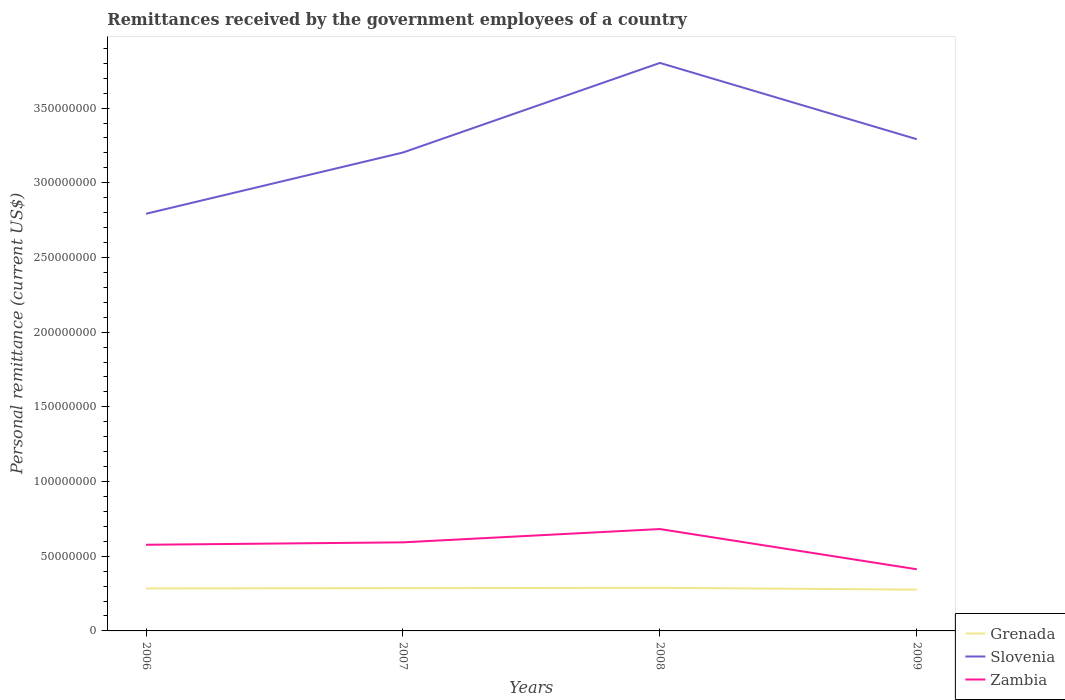Is the number of lines equal to the number of legend labels?
Your response must be concise. Yes. Across all years, what is the maximum remittances received by the government employees in Slovenia?
Offer a very short reply. 2.79e+08. In which year was the remittances received by the government employees in Slovenia maximum?
Offer a terse response. 2006. What is the total remittances received by the government employees in Zambia in the graph?
Your response must be concise. 1.64e+07. What is the difference between the highest and the second highest remittances received by the government employees in Grenada?
Provide a short and direct response. 1.20e+06. What is the difference between the highest and the lowest remittances received by the government employees in Grenada?
Make the answer very short. 3. What is the difference between two consecutive major ticks on the Y-axis?
Your answer should be very brief. 5.00e+07. Does the graph contain any zero values?
Give a very brief answer. No. Does the graph contain grids?
Your answer should be compact. No. Where does the legend appear in the graph?
Provide a short and direct response. Bottom right. How are the legend labels stacked?
Keep it short and to the point. Vertical. What is the title of the graph?
Ensure brevity in your answer.  Remittances received by the government employees of a country. Does "Tonga" appear as one of the legend labels in the graph?
Your answer should be compact. No. What is the label or title of the Y-axis?
Your response must be concise. Personal remittance (current US$). What is the Personal remittance (current US$) in Grenada in 2006?
Your answer should be compact. 2.84e+07. What is the Personal remittance (current US$) in Slovenia in 2006?
Provide a succinct answer. 2.79e+08. What is the Personal remittance (current US$) of Zambia in 2006?
Provide a short and direct response. 5.77e+07. What is the Personal remittance (current US$) of Grenada in 2007?
Keep it short and to the point. 2.86e+07. What is the Personal remittance (current US$) in Slovenia in 2007?
Your answer should be very brief. 3.20e+08. What is the Personal remittance (current US$) of Zambia in 2007?
Provide a succinct answer. 5.93e+07. What is the Personal remittance (current US$) of Grenada in 2008?
Give a very brief answer. 2.89e+07. What is the Personal remittance (current US$) in Slovenia in 2008?
Offer a very short reply. 3.80e+08. What is the Personal remittance (current US$) in Zambia in 2008?
Offer a terse response. 6.82e+07. What is the Personal remittance (current US$) of Grenada in 2009?
Provide a short and direct response. 2.77e+07. What is the Personal remittance (current US$) in Slovenia in 2009?
Keep it short and to the point. 3.29e+08. What is the Personal remittance (current US$) of Zambia in 2009?
Offer a very short reply. 4.13e+07. Across all years, what is the maximum Personal remittance (current US$) in Grenada?
Your response must be concise. 2.89e+07. Across all years, what is the maximum Personal remittance (current US$) of Slovenia?
Offer a very short reply. 3.80e+08. Across all years, what is the maximum Personal remittance (current US$) in Zambia?
Make the answer very short. 6.82e+07. Across all years, what is the minimum Personal remittance (current US$) in Grenada?
Offer a terse response. 2.77e+07. Across all years, what is the minimum Personal remittance (current US$) of Slovenia?
Your answer should be very brief. 2.79e+08. Across all years, what is the minimum Personal remittance (current US$) in Zambia?
Your answer should be very brief. 4.13e+07. What is the total Personal remittance (current US$) in Grenada in the graph?
Keep it short and to the point. 1.14e+08. What is the total Personal remittance (current US$) of Slovenia in the graph?
Your answer should be compact. 1.31e+09. What is the total Personal remittance (current US$) of Zambia in the graph?
Your response must be concise. 2.26e+08. What is the difference between the Personal remittance (current US$) in Grenada in 2006 and that in 2007?
Make the answer very short. -1.82e+05. What is the difference between the Personal remittance (current US$) in Slovenia in 2006 and that in 2007?
Your response must be concise. -4.10e+07. What is the difference between the Personal remittance (current US$) of Zambia in 2006 and that in 2007?
Offer a terse response. -1.62e+06. What is the difference between the Personal remittance (current US$) of Grenada in 2006 and that in 2008?
Keep it short and to the point. -4.07e+05. What is the difference between the Personal remittance (current US$) in Slovenia in 2006 and that in 2008?
Provide a short and direct response. -1.01e+08. What is the difference between the Personal remittance (current US$) in Zambia in 2006 and that in 2008?
Keep it short and to the point. -1.05e+07. What is the difference between the Personal remittance (current US$) of Grenada in 2006 and that in 2009?
Your answer should be very brief. 7.91e+05. What is the difference between the Personal remittance (current US$) in Slovenia in 2006 and that in 2009?
Provide a short and direct response. -4.99e+07. What is the difference between the Personal remittance (current US$) of Zambia in 2006 and that in 2009?
Your response must be concise. 1.64e+07. What is the difference between the Personal remittance (current US$) of Grenada in 2007 and that in 2008?
Give a very brief answer. -2.25e+05. What is the difference between the Personal remittance (current US$) of Slovenia in 2007 and that in 2008?
Ensure brevity in your answer.  -6.00e+07. What is the difference between the Personal remittance (current US$) in Zambia in 2007 and that in 2008?
Your answer should be very brief. -8.90e+06. What is the difference between the Personal remittance (current US$) of Grenada in 2007 and that in 2009?
Make the answer very short. 9.72e+05. What is the difference between the Personal remittance (current US$) in Slovenia in 2007 and that in 2009?
Your response must be concise. -8.91e+06. What is the difference between the Personal remittance (current US$) of Zambia in 2007 and that in 2009?
Your answer should be very brief. 1.80e+07. What is the difference between the Personal remittance (current US$) in Grenada in 2008 and that in 2009?
Your answer should be compact. 1.20e+06. What is the difference between the Personal remittance (current US$) of Slovenia in 2008 and that in 2009?
Offer a terse response. 5.11e+07. What is the difference between the Personal remittance (current US$) in Zambia in 2008 and that in 2009?
Your response must be concise. 2.69e+07. What is the difference between the Personal remittance (current US$) of Grenada in 2006 and the Personal remittance (current US$) of Slovenia in 2007?
Provide a succinct answer. -2.92e+08. What is the difference between the Personal remittance (current US$) in Grenada in 2006 and the Personal remittance (current US$) in Zambia in 2007?
Your answer should be very brief. -3.09e+07. What is the difference between the Personal remittance (current US$) of Slovenia in 2006 and the Personal remittance (current US$) of Zambia in 2007?
Your answer should be compact. 2.20e+08. What is the difference between the Personal remittance (current US$) in Grenada in 2006 and the Personal remittance (current US$) in Slovenia in 2008?
Keep it short and to the point. -3.52e+08. What is the difference between the Personal remittance (current US$) in Grenada in 2006 and the Personal remittance (current US$) in Zambia in 2008?
Offer a very short reply. -3.98e+07. What is the difference between the Personal remittance (current US$) of Slovenia in 2006 and the Personal remittance (current US$) of Zambia in 2008?
Your answer should be very brief. 2.11e+08. What is the difference between the Personal remittance (current US$) of Grenada in 2006 and the Personal remittance (current US$) of Slovenia in 2009?
Your answer should be very brief. -3.01e+08. What is the difference between the Personal remittance (current US$) in Grenada in 2006 and the Personal remittance (current US$) in Zambia in 2009?
Offer a terse response. -1.28e+07. What is the difference between the Personal remittance (current US$) in Slovenia in 2006 and the Personal remittance (current US$) in Zambia in 2009?
Offer a very short reply. 2.38e+08. What is the difference between the Personal remittance (current US$) of Grenada in 2007 and the Personal remittance (current US$) of Slovenia in 2008?
Offer a very short reply. -3.52e+08. What is the difference between the Personal remittance (current US$) in Grenada in 2007 and the Personal remittance (current US$) in Zambia in 2008?
Keep it short and to the point. -3.96e+07. What is the difference between the Personal remittance (current US$) in Slovenia in 2007 and the Personal remittance (current US$) in Zambia in 2008?
Give a very brief answer. 2.52e+08. What is the difference between the Personal remittance (current US$) of Grenada in 2007 and the Personal remittance (current US$) of Slovenia in 2009?
Keep it short and to the point. -3.01e+08. What is the difference between the Personal remittance (current US$) of Grenada in 2007 and the Personal remittance (current US$) of Zambia in 2009?
Offer a very short reply. -1.26e+07. What is the difference between the Personal remittance (current US$) of Slovenia in 2007 and the Personal remittance (current US$) of Zambia in 2009?
Provide a succinct answer. 2.79e+08. What is the difference between the Personal remittance (current US$) of Grenada in 2008 and the Personal remittance (current US$) of Slovenia in 2009?
Provide a succinct answer. -3.00e+08. What is the difference between the Personal remittance (current US$) of Grenada in 2008 and the Personal remittance (current US$) of Zambia in 2009?
Your answer should be very brief. -1.24e+07. What is the difference between the Personal remittance (current US$) of Slovenia in 2008 and the Personal remittance (current US$) of Zambia in 2009?
Provide a short and direct response. 3.39e+08. What is the average Personal remittance (current US$) of Grenada per year?
Keep it short and to the point. 2.84e+07. What is the average Personal remittance (current US$) in Slovenia per year?
Ensure brevity in your answer.  3.27e+08. What is the average Personal remittance (current US$) of Zambia per year?
Ensure brevity in your answer.  5.66e+07. In the year 2006, what is the difference between the Personal remittance (current US$) in Grenada and Personal remittance (current US$) in Slovenia?
Ensure brevity in your answer.  -2.51e+08. In the year 2006, what is the difference between the Personal remittance (current US$) of Grenada and Personal remittance (current US$) of Zambia?
Make the answer very short. -2.92e+07. In the year 2006, what is the difference between the Personal remittance (current US$) in Slovenia and Personal remittance (current US$) in Zambia?
Provide a short and direct response. 2.22e+08. In the year 2007, what is the difference between the Personal remittance (current US$) in Grenada and Personal remittance (current US$) in Slovenia?
Provide a short and direct response. -2.92e+08. In the year 2007, what is the difference between the Personal remittance (current US$) in Grenada and Personal remittance (current US$) in Zambia?
Your answer should be very brief. -3.07e+07. In the year 2007, what is the difference between the Personal remittance (current US$) of Slovenia and Personal remittance (current US$) of Zambia?
Provide a short and direct response. 2.61e+08. In the year 2008, what is the difference between the Personal remittance (current US$) of Grenada and Personal remittance (current US$) of Slovenia?
Make the answer very short. -3.51e+08. In the year 2008, what is the difference between the Personal remittance (current US$) in Grenada and Personal remittance (current US$) in Zambia?
Provide a short and direct response. -3.93e+07. In the year 2008, what is the difference between the Personal remittance (current US$) of Slovenia and Personal remittance (current US$) of Zambia?
Make the answer very short. 3.12e+08. In the year 2009, what is the difference between the Personal remittance (current US$) in Grenada and Personal remittance (current US$) in Slovenia?
Ensure brevity in your answer.  -3.02e+08. In the year 2009, what is the difference between the Personal remittance (current US$) in Grenada and Personal remittance (current US$) in Zambia?
Your response must be concise. -1.36e+07. In the year 2009, what is the difference between the Personal remittance (current US$) in Slovenia and Personal remittance (current US$) in Zambia?
Your response must be concise. 2.88e+08. What is the ratio of the Personal remittance (current US$) of Grenada in 2006 to that in 2007?
Make the answer very short. 0.99. What is the ratio of the Personal remittance (current US$) of Slovenia in 2006 to that in 2007?
Offer a terse response. 0.87. What is the ratio of the Personal remittance (current US$) in Zambia in 2006 to that in 2007?
Your answer should be compact. 0.97. What is the ratio of the Personal remittance (current US$) in Grenada in 2006 to that in 2008?
Provide a short and direct response. 0.99. What is the ratio of the Personal remittance (current US$) in Slovenia in 2006 to that in 2008?
Ensure brevity in your answer.  0.73. What is the ratio of the Personal remittance (current US$) in Zambia in 2006 to that in 2008?
Your answer should be very brief. 0.85. What is the ratio of the Personal remittance (current US$) in Grenada in 2006 to that in 2009?
Provide a succinct answer. 1.03. What is the ratio of the Personal remittance (current US$) in Slovenia in 2006 to that in 2009?
Provide a short and direct response. 0.85. What is the ratio of the Personal remittance (current US$) in Zambia in 2006 to that in 2009?
Ensure brevity in your answer.  1.4. What is the ratio of the Personal remittance (current US$) in Grenada in 2007 to that in 2008?
Provide a short and direct response. 0.99. What is the ratio of the Personal remittance (current US$) of Slovenia in 2007 to that in 2008?
Offer a terse response. 0.84. What is the ratio of the Personal remittance (current US$) of Zambia in 2007 to that in 2008?
Your answer should be compact. 0.87. What is the ratio of the Personal remittance (current US$) of Grenada in 2007 to that in 2009?
Offer a terse response. 1.04. What is the ratio of the Personal remittance (current US$) of Slovenia in 2007 to that in 2009?
Offer a terse response. 0.97. What is the ratio of the Personal remittance (current US$) of Zambia in 2007 to that in 2009?
Your answer should be very brief. 1.44. What is the ratio of the Personal remittance (current US$) in Grenada in 2008 to that in 2009?
Provide a succinct answer. 1.04. What is the ratio of the Personal remittance (current US$) of Slovenia in 2008 to that in 2009?
Provide a succinct answer. 1.16. What is the ratio of the Personal remittance (current US$) of Zambia in 2008 to that in 2009?
Keep it short and to the point. 1.65. What is the difference between the highest and the second highest Personal remittance (current US$) of Grenada?
Offer a very short reply. 2.25e+05. What is the difference between the highest and the second highest Personal remittance (current US$) in Slovenia?
Provide a succinct answer. 5.11e+07. What is the difference between the highest and the second highest Personal remittance (current US$) of Zambia?
Your answer should be very brief. 8.90e+06. What is the difference between the highest and the lowest Personal remittance (current US$) in Grenada?
Offer a terse response. 1.20e+06. What is the difference between the highest and the lowest Personal remittance (current US$) of Slovenia?
Make the answer very short. 1.01e+08. What is the difference between the highest and the lowest Personal remittance (current US$) in Zambia?
Your answer should be compact. 2.69e+07. 